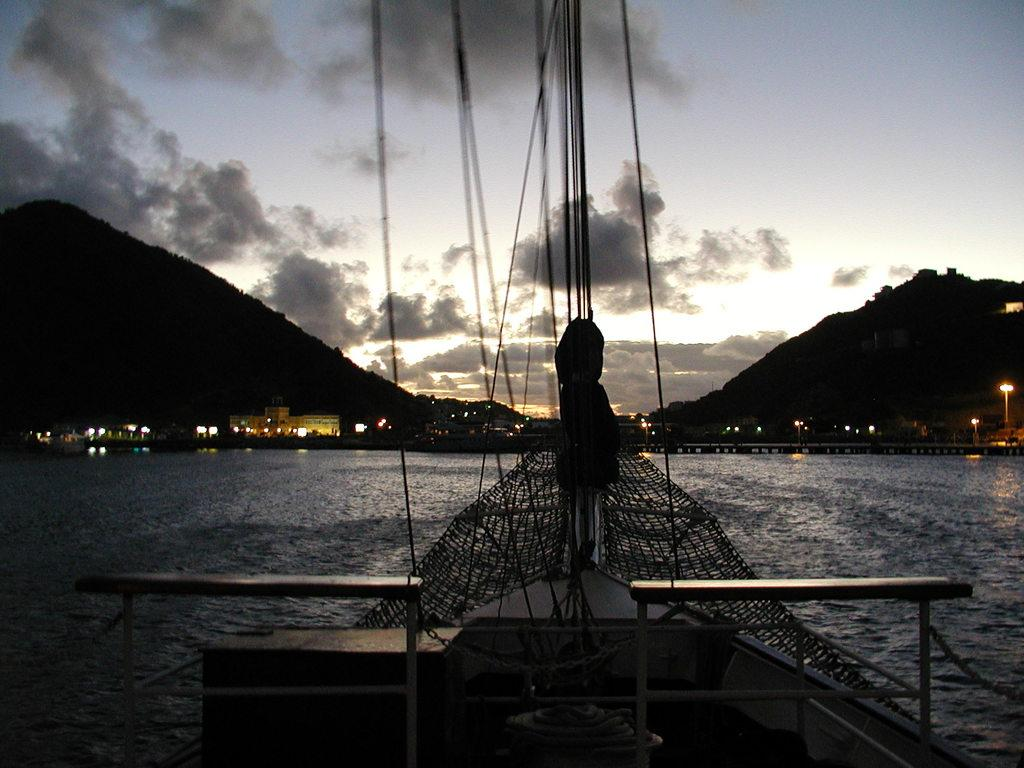What is the main subject of the image? There is a ship in the image. Where is the ship located? The ship is on the water. What can be seen in the background of the image? There are buildings, poles, lights, hills, and the sky visible in the background of the image. What type of plate is being used to serve the comfort food in the image? There is no plate or comfort food present in the image. 